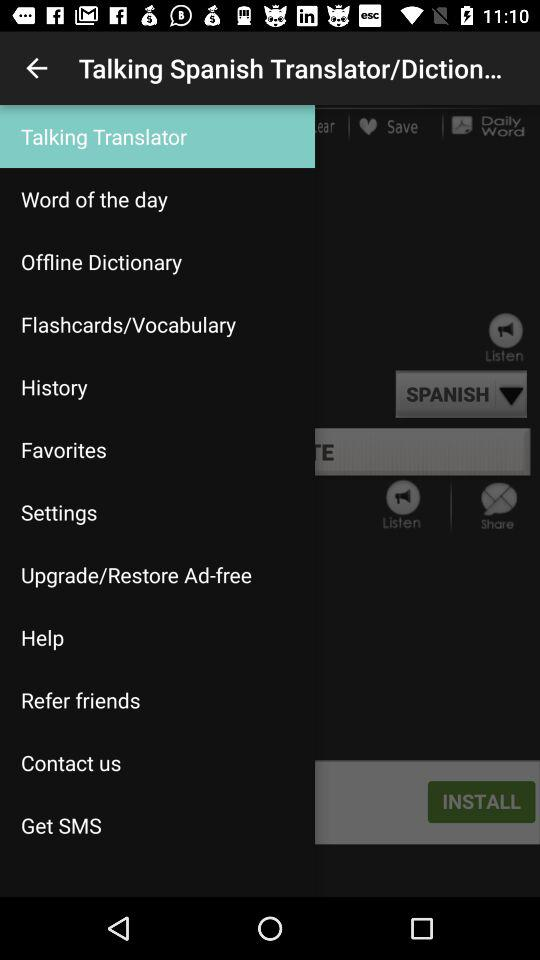Which is the selected tab? The selected tab is "Talking Translator". 